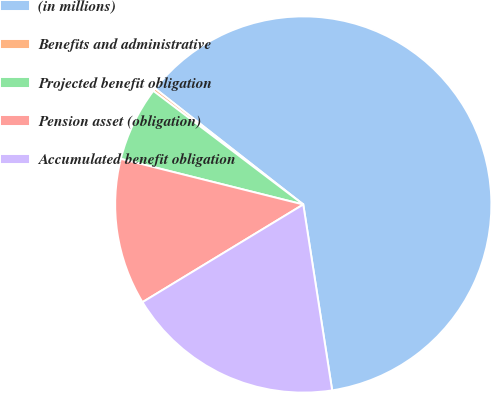Convert chart. <chart><loc_0><loc_0><loc_500><loc_500><pie_chart><fcel>(in millions)<fcel>Benefits and administrative<fcel>Projected benefit obligation<fcel>Pension asset (obligation)<fcel>Accumulated benefit obligation<nl><fcel>61.98%<fcel>0.25%<fcel>6.42%<fcel>12.59%<fcel>18.77%<nl></chart> 